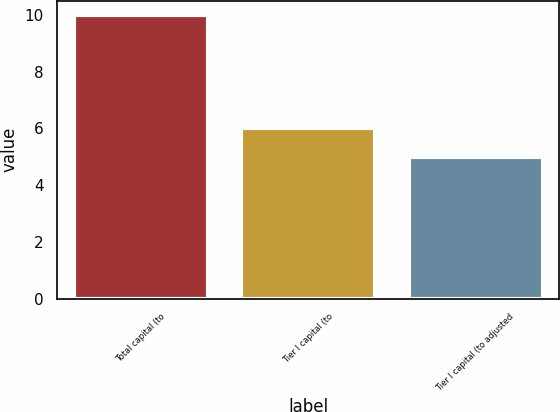Convert chart to OTSL. <chart><loc_0><loc_0><loc_500><loc_500><bar_chart><fcel>Total capital (to<fcel>Tier I capital (to<fcel>Tier I capital (to adjusted<nl><fcel>10<fcel>6<fcel>5<nl></chart> 